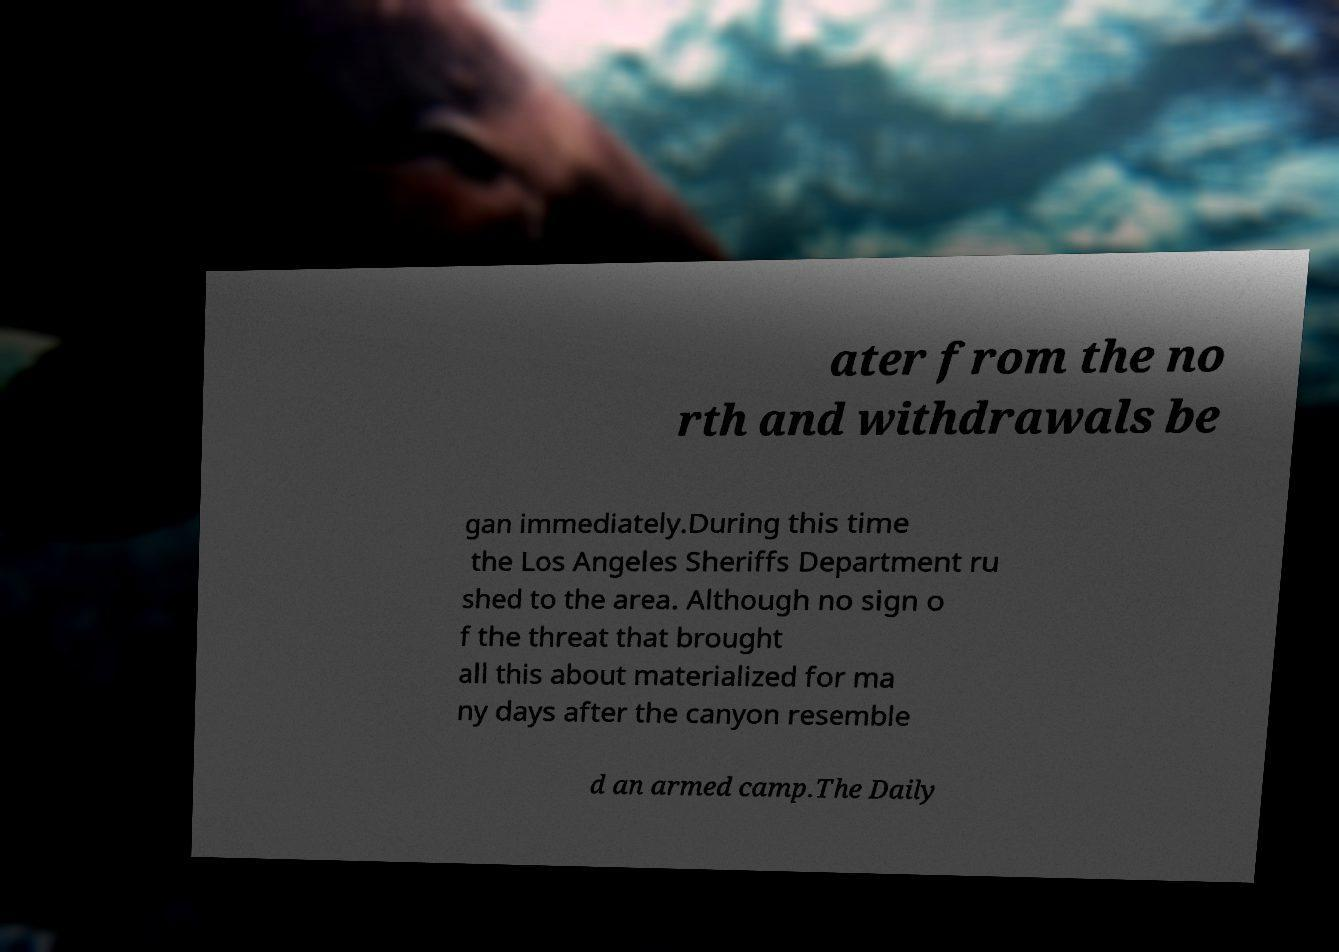I need the written content from this picture converted into text. Can you do that? ater from the no rth and withdrawals be gan immediately.During this time the Los Angeles Sheriffs Department ru shed to the area. Although no sign o f the threat that brought all this about materialized for ma ny days after the canyon resemble d an armed camp.The Daily 